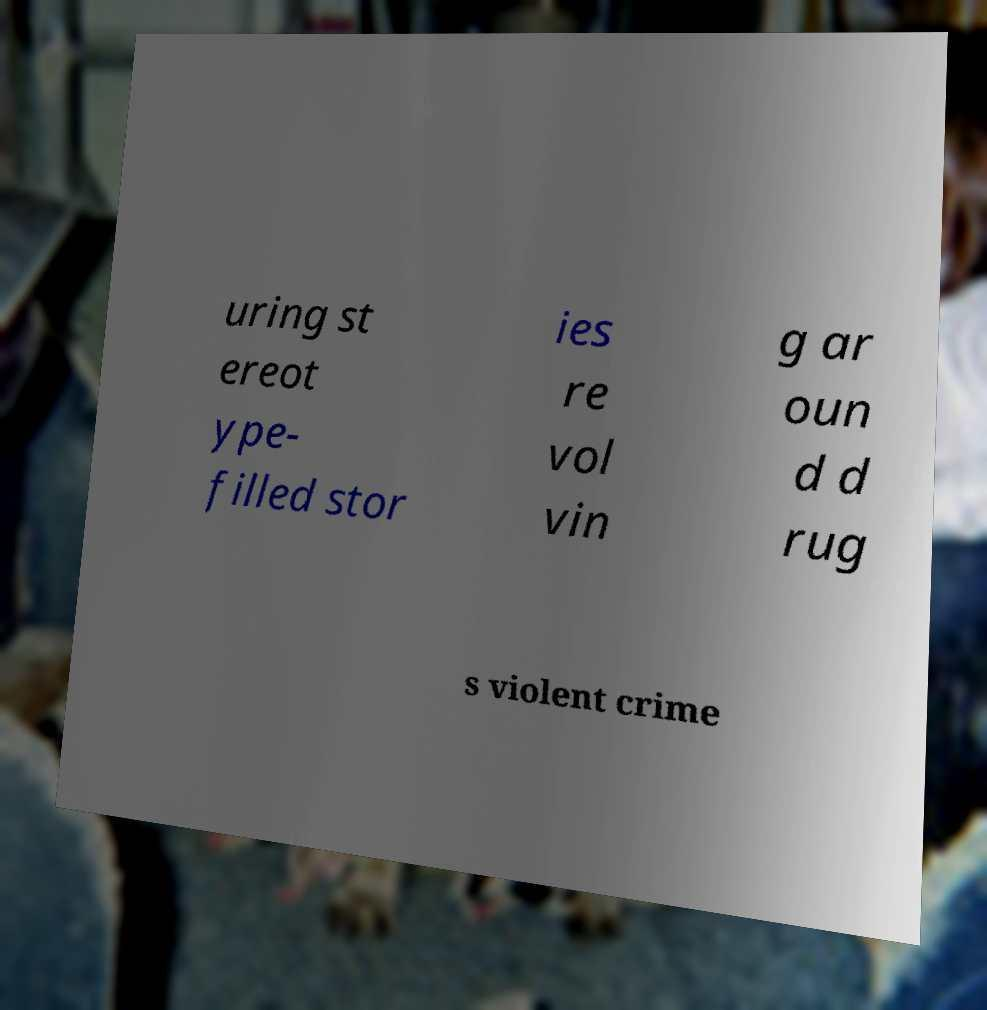Can you read and provide the text displayed in the image?This photo seems to have some interesting text. Can you extract and type it out for me? uring st ereot ype- filled stor ies re vol vin g ar oun d d rug s violent crime 